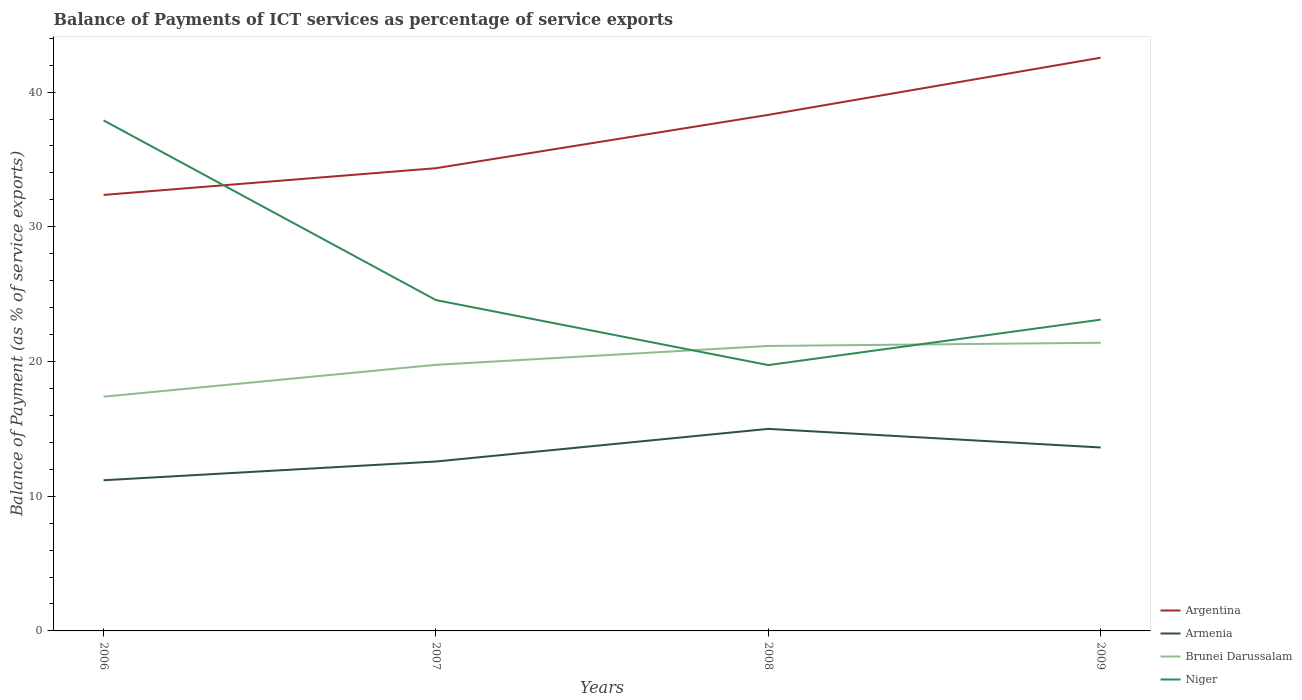Does the line corresponding to Armenia intersect with the line corresponding to Brunei Darussalam?
Provide a short and direct response. No. Across all years, what is the maximum balance of payments of ICT services in Argentina?
Offer a terse response. 32.36. What is the total balance of payments of ICT services in Argentina in the graph?
Offer a very short reply. -3.96. What is the difference between the highest and the second highest balance of payments of ICT services in Brunei Darussalam?
Give a very brief answer. 4. Is the balance of payments of ICT services in Armenia strictly greater than the balance of payments of ICT services in Brunei Darussalam over the years?
Offer a terse response. Yes. Does the graph contain any zero values?
Make the answer very short. No. Does the graph contain grids?
Your answer should be very brief. No. How are the legend labels stacked?
Provide a short and direct response. Vertical. What is the title of the graph?
Offer a very short reply. Balance of Payments of ICT services as percentage of service exports. What is the label or title of the X-axis?
Provide a short and direct response. Years. What is the label or title of the Y-axis?
Keep it short and to the point. Balance of Payment (as % of service exports). What is the Balance of Payment (as % of service exports) of Argentina in 2006?
Your answer should be compact. 32.36. What is the Balance of Payment (as % of service exports) in Armenia in 2006?
Your answer should be compact. 11.18. What is the Balance of Payment (as % of service exports) in Brunei Darussalam in 2006?
Offer a very short reply. 17.39. What is the Balance of Payment (as % of service exports) in Niger in 2006?
Offer a terse response. 37.9. What is the Balance of Payment (as % of service exports) in Argentina in 2007?
Your response must be concise. 34.35. What is the Balance of Payment (as % of service exports) in Armenia in 2007?
Provide a short and direct response. 12.58. What is the Balance of Payment (as % of service exports) in Brunei Darussalam in 2007?
Provide a short and direct response. 19.75. What is the Balance of Payment (as % of service exports) of Niger in 2007?
Make the answer very short. 24.56. What is the Balance of Payment (as % of service exports) of Argentina in 2008?
Give a very brief answer. 38.31. What is the Balance of Payment (as % of service exports) in Armenia in 2008?
Provide a succinct answer. 15. What is the Balance of Payment (as % of service exports) in Brunei Darussalam in 2008?
Offer a very short reply. 21.15. What is the Balance of Payment (as % of service exports) in Niger in 2008?
Ensure brevity in your answer.  19.73. What is the Balance of Payment (as % of service exports) of Argentina in 2009?
Your answer should be very brief. 42.55. What is the Balance of Payment (as % of service exports) in Armenia in 2009?
Your answer should be compact. 13.62. What is the Balance of Payment (as % of service exports) in Brunei Darussalam in 2009?
Your response must be concise. 21.39. What is the Balance of Payment (as % of service exports) of Niger in 2009?
Offer a terse response. 23.11. Across all years, what is the maximum Balance of Payment (as % of service exports) of Argentina?
Give a very brief answer. 42.55. Across all years, what is the maximum Balance of Payment (as % of service exports) in Armenia?
Ensure brevity in your answer.  15. Across all years, what is the maximum Balance of Payment (as % of service exports) of Brunei Darussalam?
Give a very brief answer. 21.39. Across all years, what is the maximum Balance of Payment (as % of service exports) of Niger?
Give a very brief answer. 37.9. Across all years, what is the minimum Balance of Payment (as % of service exports) in Argentina?
Offer a terse response. 32.36. Across all years, what is the minimum Balance of Payment (as % of service exports) in Armenia?
Offer a terse response. 11.18. Across all years, what is the minimum Balance of Payment (as % of service exports) of Brunei Darussalam?
Your answer should be very brief. 17.39. Across all years, what is the minimum Balance of Payment (as % of service exports) of Niger?
Offer a very short reply. 19.73. What is the total Balance of Payment (as % of service exports) of Argentina in the graph?
Provide a succinct answer. 147.57. What is the total Balance of Payment (as % of service exports) in Armenia in the graph?
Your answer should be very brief. 52.38. What is the total Balance of Payment (as % of service exports) of Brunei Darussalam in the graph?
Your answer should be very brief. 79.69. What is the total Balance of Payment (as % of service exports) of Niger in the graph?
Offer a very short reply. 105.3. What is the difference between the Balance of Payment (as % of service exports) of Argentina in 2006 and that in 2007?
Provide a succinct answer. -1.98. What is the difference between the Balance of Payment (as % of service exports) in Armenia in 2006 and that in 2007?
Provide a succinct answer. -1.39. What is the difference between the Balance of Payment (as % of service exports) of Brunei Darussalam in 2006 and that in 2007?
Offer a very short reply. -2.37. What is the difference between the Balance of Payment (as % of service exports) in Niger in 2006 and that in 2007?
Offer a terse response. 13.34. What is the difference between the Balance of Payment (as % of service exports) of Argentina in 2006 and that in 2008?
Provide a short and direct response. -5.94. What is the difference between the Balance of Payment (as % of service exports) of Armenia in 2006 and that in 2008?
Provide a succinct answer. -3.81. What is the difference between the Balance of Payment (as % of service exports) of Brunei Darussalam in 2006 and that in 2008?
Give a very brief answer. -3.77. What is the difference between the Balance of Payment (as % of service exports) of Niger in 2006 and that in 2008?
Keep it short and to the point. 18.16. What is the difference between the Balance of Payment (as % of service exports) in Argentina in 2006 and that in 2009?
Keep it short and to the point. -10.19. What is the difference between the Balance of Payment (as % of service exports) of Armenia in 2006 and that in 2009?
Keep it short and to the point. -2.43. What is the difference between the Balance of Payment (as % of service exports) in Brunei Darussalam in 2006 and that in 2009?
Offer a very short reply. -4. What is the difference between the Balance of Payment (as % of service exports) of Niger in 2006 and that in 2009?
Provide a succinct answer. 14.79. What is the difference between the Balance of Payment (as % of service exports) in Argentina in 2007 and that in 2008?
Your answer should be compact. -3.96. What is the difference between the Balance of Payment (as % of service exports) of Armenia in 2007 and that in 2008?
Offer a very short reply. -2.42. What is the difference between the Balance of Payment (as % of service exports) in Brunei Darussalam in 2007 and that in 2008?
Provide a short and direct response. -1.4. What is the difference between the Balance of Payment (as % of service exports) of Niger in 2007 and that in 2008?
Offer a terse response. 4.83. What is the difference between the Balance of Payment (as % of service exports) in Argentina in 2007 and that in 2009?
Your answer should be very brief. -8.2. What is the difference between the Balance of Payment (as % of service exports) of Armenia in 2007 and that in 2009?
Provide a short and direct response. -1.04. What is the difference between the Balance of Payment (as % of service exports) in Brunei Darussalam in 2007 and that in 2009?
Your answer should be very brief. -1.64. What is the difference between the Balance of Payment (as % of service exports) of Niger in 2007 and that in 2009?
Provide a succinct answer. 1.45. What is the difference between the Balance of Payment (as % of service exports) of Argentina in 2008 and that in 2009?
Your response must be concise. -4.24. What is the difference between the Balance of Payment (as % of service exports) of Armenia in 2008 and that in 2009?
Offer a very short reply. 1.38. What is the difference between the Balance of Payment (as % of service exports) in Brunei Darussalam in 2008 and that in 2009?
Keep it short and to the point. -0.24. What is the difference between the Balance of Payment (as % of service exports) in Niger in 2008 and that in 2009?
Offer a terse response. -3.37. What is the difference between the Balance of Payment (as % of service exports) in Argentina in 2006 and the Balance of Payment (as % of service exports) in Armenia in 2007?
Your response must be concise. 19.79. What is the difference between the Balance of Payment (as % of service exports) of Argentina in 2006 and the Balance of Payment (as % of service exports) of Brunei Darussalam in 2007?
Provide a short and direct response. 12.61. What is the difference between the Balance of Payment (as % of service exports) in Argentina in 2006 and the Balance of Payment (as % of service exports) in Niger in 2007?
Give a very brief answer. 7.81. What is the difference between the Balance of Payment (as % of service exports) in Armenia in 2006 and the Balance of Payment (as % of service exports) in Brunei Darussalam in 2007?
Your answer should be compact. -8.57. What is the difference between the Balance of Payment (as % of service exports) in Armenia in 2006 and the Balance of Payment (as % of service exports) in Niger in 2007?
Your response must be concise. -13.38. What is the difference between the Balance of Payment (as % of service exports) in Brunei Darussalam in 2006 and the Balance of Payment (as % of service exports) in Niger in 2007?
Make the answer very short. -7.17. What is the difference between the Balance of Payment (as % of service exports) of Argentina in 2006 and the Balance of Payment (as % of service exports) of Armenia in 2008?
Offer a very short reply. 17.37. What is the difference between the Balance of Payment (as % of service exports) of Argentina in 2006 and the Balance of Payment (as % of service exports) of Brunei Darussalam in 2008?
Your answer should be compact. 11.21. What is the difference between the Balance of Payment (as % of service exports) in Argentina in 2006 and the Balance of Payment (as % of service exports) in Niger in 2008?
Keep it short and to the point. 12.63. What is the difference between the Balance of Payment (as % of service exports) of Armenia in 2006 and the Balance of Payment (as % of service exports) of Brunei Darussalam in 2008?
Keep it short and to the point. -9.97. What is the difference between the Balance of Payment (as % of service exports) in Armenia in 2006 and the Balance of Payment (as % of service exports) in Niger in 2008?
Your answer should be compact. -8.55. What is the difference between the Balance of Payment (as % of service exports) of Brunei Darussalam in 2006 and the Balance of Payment (as % of service exports) of Niger in 2008?
Your response must be concise. -2.35. What is the difference between the Balance of Payment (as % of service exports) of Argentina in 2006 and the Balance of Payment (as % of service exports) of Armenia in 2009?
Offer a terse response. 18.75. What is the difference between the Balance of Payment (as % of service exports) in Argentina in 2006 and the Balance of Payment (as % of service exports) in Brunei Darussalam in 2009?
Offer a terse response. 10.97. What is the difference between the Balance of Payment (as % of service exports) of Argentina in 2006 and the Balance of Payment (as % of service exports) of Niger in 2009?
Your answer should be very brief. 9.26. What is the difference between the Balance of Payment (as % of service exports) in Armenia in 2006 and the Balance of Payment (as % of service exports) in Brunei Darussalam in 2009?
Your response must be concise. -10.21. What is the difference between the Balance of Payment (as % of service exports) of Armenia in 2006 and the Balance of Payment (as % of service exports) of Niger in 2009?
Provide a succinct answer. -11.92. What is the difference between the Balance of Payment (as % of service exports) in Brunei Darussalam in 2006 and the Balance of Payment (as % of service exports) in Niger in 2009?
Your answer should be compact. -5.72. What is the difference between the Balance of Payment (as % of service exports) of Argentina in 2007 and the Balance of Payment (as % of service exports) of Armenia in 2008?
Keep it short and to the point. 19.35. What is the difference between the Balance of Payment (as % of service exports) in Argentina in 2007 and the Balance of Payment (as % of service exports) in Brunei Darussalam in 2008?
Ensure brevity in your answer.  13.2. What is the difference between the Balance of Payment (as % of service exports) of Argentina in 2007 and the Balance of Payment (as % of service exports) of Niger in 2008?
Your answer should be compact. 14.62. What is the difference between the Balance of Payment (as % of service exports) of Armenia in 2007 and the Balance of Payment (as % of service exports) of Brunei Darussalam in 2008?
Keep it short and to the point. -8.58. What is the difference between the Balance of Payment (as % of service exports) of Armenia in 2007 and the Balance of Payment (as % of service exports) of Niger in 2008?
Provide a short and direct response. -7.16. What is the difference between the Balance of Payment (as % of service exports) in Brunei Darussalam in 2007 and the Balance of Payment (as % of service exports) in Niger in 2008?
Provide a short and direct response. 0.02. What is the difference between the Balance of Payment (as % of service exports) in Argentina in 2007 and the Balance of Payment (as % of service exports) in Armenia in 2009?
Give a very brief answer. 20.73. What is the difference between the Balance of Payment (as % of service exports) of Argentina in 2007 and the Balance of Payment (as % of service exports) of Brunei Darussalam in 2009?
Your response must be concise. 12.96. What is the difference between the Balance of Payment (as % of service exports) of Argentina in 2007 and the Balance of Payment (as % of service exports) of Niger in 2009?
Ensure brevity in your answer.  11.24. What is the difference between the Balance of Payment (as % of service exports) of Armenia in 2007 and the Balance of Payment (as % of service exports) of Brunei Darussalam in 2009?
Give a very brief answer. -8.82. What is the difference between the Balance of Payment (as % of service exports) in Armenia in 2007 and the Balance of Payment (as % of service exports) in Niger in 2009?
Offer a terse response. -10.53. What is the difference between the Balance of Payment (as % of service exports) in Brunei Darussalam in 2007 and the Balance of Payment (as % of service exports) in Niger in 2009?
Your answer should be very brief. -3.35. What is the difference between the Balance of Payment (as % of service exports) in Argentina in 2008 and the Balance of Payment (as % of service exports) in Armenia in 2009?
Provide a short and direct response. 24.69. What is the difference between the Balance of Payment (as % of service exports) in Argentina in 2008 and the Balance of Payment (as % of service exports) in Brunei Darussalam in 2009?
Your answer should be compact. 16.92. What is the difference between the Balance of Payment (as % of service exports) of Argentina in 2008 and the Balance of Payment (as % of service exports) of Niger in 2009?
Your answer should be very brief. 15.2. What is the difference between the Balance of Payment (as % of service exports) of Armenia in 2008 and the Balance of Payment (as % of service exports) of Brunei Darussalam in 2009?
Provide a short and direct response. -6.39. What is the difference between the Balance of Payment (as % of service exports) of Armenia in 2008 and the Balance of Payment (as % of service exports) of Niger in 2009?
Make the answer very short. -8.11. What is the difference between the Balance of Payment (as % of service exports) in Brunei Darussalam in 2008 and the Balance of Payment (as % of service exports) in Niger in 2009?
Offer a very short reply. -1.95. What is the average Balance of Payment (as % of service exports) of Argentina per year?
Keep it short and to the point. 36.89. What is the average Balance of Payment (as % of service exports) in Armenia per year?
Give a very brief answer. 13.09. What is the average Balance of Payment (as % of service exports) of Brunei Darussalam per year?
Offer a terse response. 19.92. What is the average Balance of Payment (as % of service exports) of Niger per year?
Offer a terse response. 26.32. In the year 2006, what is the difference between the Balance of Payment (as % of service exports) in Argentina and Balance of Payment (as % of service exports) in Armenia?
Ensure brevity in your answer.  21.18. In the year 2006, what is the difference between the Balance of Payment (as % of service exports) of Argentina and Balance of Payment (as % of service exports) of Brunei Darussalam?
Give a very brief answer. 14.98. In the year 2006, what is the difference between the Balance of Payment (as % of service exports) of Argentina and Balance of Payment (as % of service exports) of Niger?
Your answer should be compact. -5.53. In the year 2006, what is the difference between the Balance of Payment (as % of service exports) in Armenia and Balance of Payment (as % of service exports) in Brunei Darussalam?
Offer a terse response. -6.2. In the year 2006, what is the difference between the Balance of Payment (as % of service exports) in Armenia and Balance of Payment (as % of service exports) in Niger?
Your response must be concise. -26.71. In the year 2006, what is the difference between the Balance of Payment (as % of service exports) of Brunei Darussalam and Balance of Payment (as % of service exports) of Niger?
Give a very brief answer. -20.51. In the year 2007, what is the difference between the Balance of Payment (as % of service exports) of Argentina and Balance of Payment (as % of service exports) of Armenia?
Your answer should be compact. 21.77. In the year 2007, what is the difference between the Balance of Payment (as % of service exports) in Argentina and Balance of Payment (as % of service exports) in Brunei Darussalam?
Ensure brevity in your answer.  14.6. In the year 2007, what is the difference between the Balance of Payment (as % of service exports) of Argentina and Balance of Payment (as % of service exports) of Niger?
Provide a short and direct response. 9.79. In the year 2007, what is the difference between the Balance of Payment (as % of service exports) of Armenia and Balance of Payment (as % of service exports) of Brunei Darussalam?
Make the answer very short. -7.18. In the year 2007, what is the difference between the Balance of Payment (as % of service exports) of Armenia and Balance of Payment (as % of service exports) of Niger?
Your response must be concise. -11.98. In the year 2007, what is the difference between the Balance of Payment (as % of service exports) of Brunei Darussalam and Balance of Payment (as % of service exports) of Niger?
Give a very brief answer. -4.81. In the year 2008, what is the difference between the Balance of Payment (as % of service exports) of Argentina and Balance of Payment (as % of service exports) of Armenia?
Your answer should be very brief. 23.31. In the year 2008, what is the difference between the Balance of Payment (as % of service exports) in Argentina and Balance of Payment (as % of service exports) in Brunei Darussalam?
Provide a short and direct response. 17.15. In the year 2008, what is the difference between the Balance of Payment (as % of service exports) in Argentina and Balance of Payment (as % of service exports) in Niger?
Keep it short and to the point. 18.57. In the year 2008, what is the difference between the Balance of Payment (as % of service exports) of Armenia and Balance of Payment (as % of service exports) of Brunei Darussalam?
Your answer should be compact. -6.16. In the year 2008, what is the difference between the Balance of Payment (as % of service exports) in Armenia and Balance of Payment (as % of service exports) in Niger?
Your answer should be very brief. -4.74. In the year 2008, what is the difference between the Balance of Payment (as % of service exports) of Brunei Darussalam and Balance of Payment (as % of service exports) of Niger?
Your answer should be very brief. 1.42. In the year 2009, what is the difference between the Balance of Payment (as % of service exports) of Argentina and Balance of Payment (as % of service exports) of Armenia?
Provide a short and direct response. 28.93. In the year 2009, what is the difference between the Balance of Payment (as % of service exports) of Argentina and Balance of Payment (as % of service exports) of Brunei Darussalam?
Provide a short and direct response. 21.16. In the year 2009, what is the difference between the Balance of Payment (as % of service exports) in Argentina and Balance of Payment (as % of service exports) in Niger?
Your response must be concise. 19.44. In the year 2009, what is the difference between the Balance of Payment (as % of service exports) of Armenia and Balance of Payment (as % of service exports) of Brunei Darussalam?
Provide a short and direct response. -7.78. In the year 2009, what is the difference between the Balance of Payment (as % of service exports) in Armenia and Balance of Payment (as % of service exports) in Niger?
Provide a short and direct response. -9.49. In the year 2009, what is the difference between the Balance of Payment (as % of service exports) in Brunei Darussalam and Balance of Payment (as % of service exports) in Niger?
Ensure brevity in your answer.  -1.71. What is the ratio of the Balance of Payment (as % of service exports) of Argentina in 2006 to that in 2007?
Provide a succinct answer. 0.94. What is the ratio of the Balance of Payment (as % of service exports) of Armenia in 2006 to that in 2007?
Keep it short and to the point. 0.89. What is the ratio of the Balance of Payment (as % of service exports) in Brunei Darussalam in 2006 to that in 2007?
Your response must be concise. 0.88. What is the ratio of the Balance of Payment (as % of service exports) of Niger in 2006 to that in 2007?
Keep it short and to the point. 1.54. What is the ratio of the Balance of Payment (as % of service exports) of Argentina in 2006 to that in 2008?
Offer a terse response. 0.84. What is the ratio of the Balance of Payment (as % of service exports) of Armenia in 2006 to that in 2008?
Offer a terse response. 0.75. What is the ratio of the Balance of Payment (as % of service exports) of Brunei Darussalam in 2006 to that in 2008?
Your answer should be compact. 0.82. What is the ratio of the Balance of Payment (as % of service exports) of Niger in 2006 to that in 2008?
Ensure brevity in your answer.  1.92. What is the ratio of the Balance of Payment (as % of service exports) of Argentina in 2006 to that in 2009?
Ensure brevity in your answer.  0.76. What is the ratio of the Balance of Payment (as % of service exports) in Armenia in 2006 to that in 2009?
Give a very brief answer. 0.82. What is the ratio of the Balance of Payment (as % of service exports) in Brunei Darussalam in 2006 to that in 2009?
Keep it short and to the point. 0.81. What is the ratio of the Balance of Payment (as % of service exports) in Niger in 2006 to that in 2009?
Provide a succinct answer. 1.64. What is the ratio of the Balance of Payment (as % of service exports) of Argentina in 2007 to that in 2008?
Keep it short and to the point. 0.9. What is the ratio of the Balance of Payment (as % of service exports) in Armenia in 2007 to that in 2008?
Provide a succinct answer. 0.84. What is the ratio of the Balance of Payment (as % of service exports) of Brunei Darussalam in 2007 to that in 2008?
Offer a terse response. 0.93. What is the ratio of the Balance of Payment (as % of service exports) of Niger in 2007 to that in 2008?
Ensure brevity in your answer.  1.24. What is the ratio of the Balance of Payment (as % of service exports) in Argentina in 2007 to that in 2009?
Ensure brevity in your answer.  0.81. What is the ratio of the Balance of Payment (as % of service exports) in Armenia in 2007 to that in 2009?
Make the answer very short. 0.92. What is the ratio of the Balance of Payment (as % of service exports) of Brunei Darussalam in 2007 to that in 2009?
Provide a succinct answer. 0.92. What is the ratio of the Balance of Payment (as % of service exports) of Niger in 2007 to that in 2009?
Your answer should be very brief. 1.06. What is the ratio of the Balance of Payment (as % of service exports) of Argentina in 2008 to that in 2009?
Offer a terse response. 0.9. What is the ratio of the Balance of Payment (as % of service exports) of Armenia in 2008 to that in 2009?
Offer a terse response. 1.1. What is the ratio of the Balance of Payment (as % of service exports) of Brunei Darussalam in 2008 to that in 2009?
Offer a terse response. 0.99. What is the ratio of the Balance of Payment (as % of service exports) in Niger in 2008 to that in 2009?
Provide a succinct answer. 0.85. What is the difference between the highest and the second highest Balance of Payment (as % of service exports) in Argentina?
Ensure brevity in your answer.  4.24. What is the difference between the highest and the second highest Balance of Payment (as % of service exports) in Armenia?
Your response must be concise. 1.38. What is the difference between the highest and the second highest Balance of Payment (as % of service exports) in Brunei Darussalam?
Provide a succinct answer. 0.24. What is the difference between the highest and the second highest Balance of Payment (as % of service exports) of Niger?
Your answer should be very brief. 13.34. What is the difference between the highest and the lowest Balance of Payment (as % of service exports) in Argentina?
Give a very brief answer. 10.19. What is the difference between the highest and the lowest Balance of Payment (as % of service exports) of Armenia?
Offer a very short reply. 3.81. What is the difference between the highest and the lowest Balance of Payment (as % of service exports) of Brunei Darussalam?
Provide a short and direct response. 4. What is the difference between the highest and the lowest Balance of Payment (as % of service exports) in Niger?
Keep it short and to the point. 18.16. 